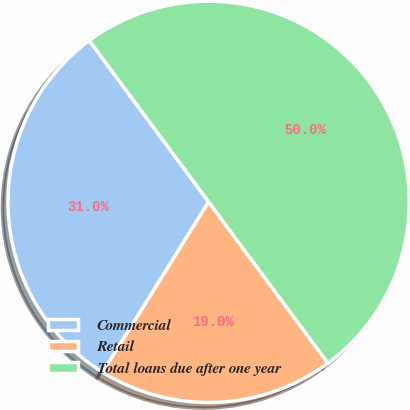<chart> <loc_0><loc_0><loc_500><loc_500><pie_chart><fcel>Commercial<fcel>Retail<fcel>Total loans due after one year<nl><fcel>31.01%<fcel>18.99%<fcel>50.0%<nl></chart> 